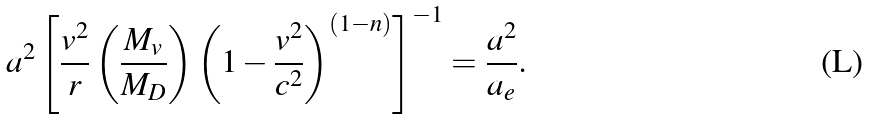<formula> <loc_0><loc_0><loc_500><loc_500>a ^ { 2 } \left [ \frac { v ^ { 2 } } { r } \left ( \frac { M _ { v } } { M _ { D } } \right ) \left ( 1 - \frac { v ^ { 2 } } { c ^ { 2 } } \right ) ^ { ( 1 - n ) } \right ] ^ { - 1 } = \frac { a ^ { 2 } } { a _ { e } } .</formula> 